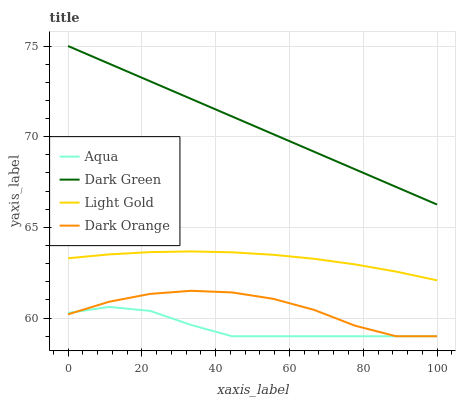Does Light Gold have the minimum area under the curve?
Answer yes or no. No. Does Light Gold have the maximum area under the curve?
Answer yes or no. No. Is Light Gold the smoothest?
Answer yes or no. No. Is Light Gold the roughest?
Answer yes or no. No. Does Light Gold have the lowest value?
Answer yes or no. No. Does Light Gold have the highest value?
Answer yes or no. No. Is Dark Orange less than Dark Green?
Answer yes or no. Yes. Is Dark Green greater than Light Gold?
Answer yes or no. Yes. Does Dark Orange intersect Dark Green?
Answer yes or no. No. 